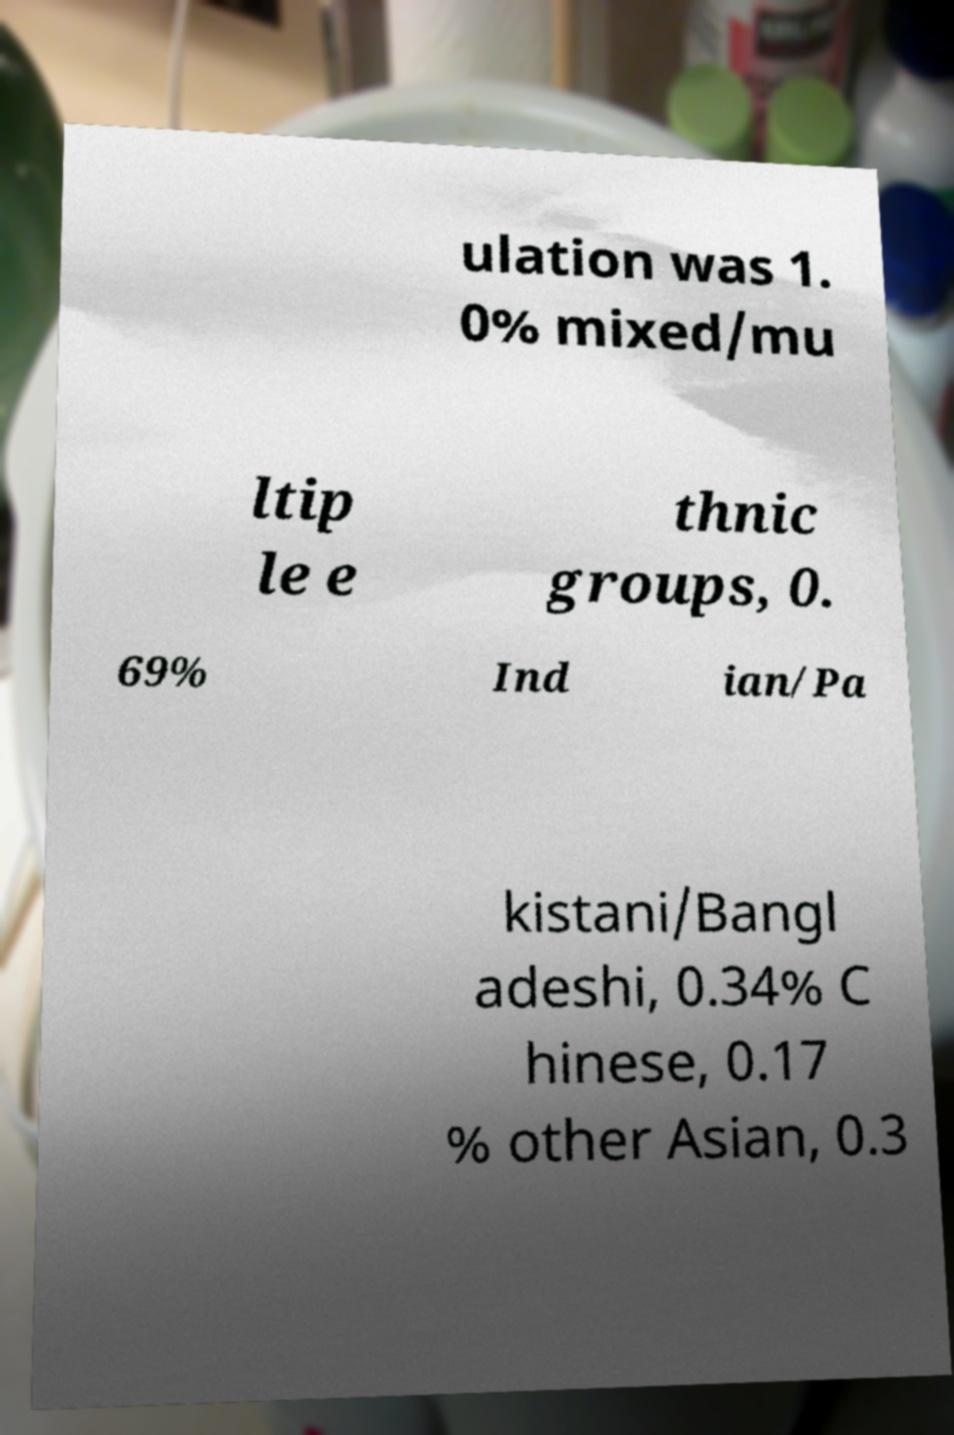Could you assist in decoding the text presented in this image and type it out clearly? ulation was 1. 0% mixed/mu ltip le e thnic groups, 0. 69% Ind ian/Pa kistani/Bangl adeshi, 0.34% C hinese, 0.17 % other Asian, 0.3 